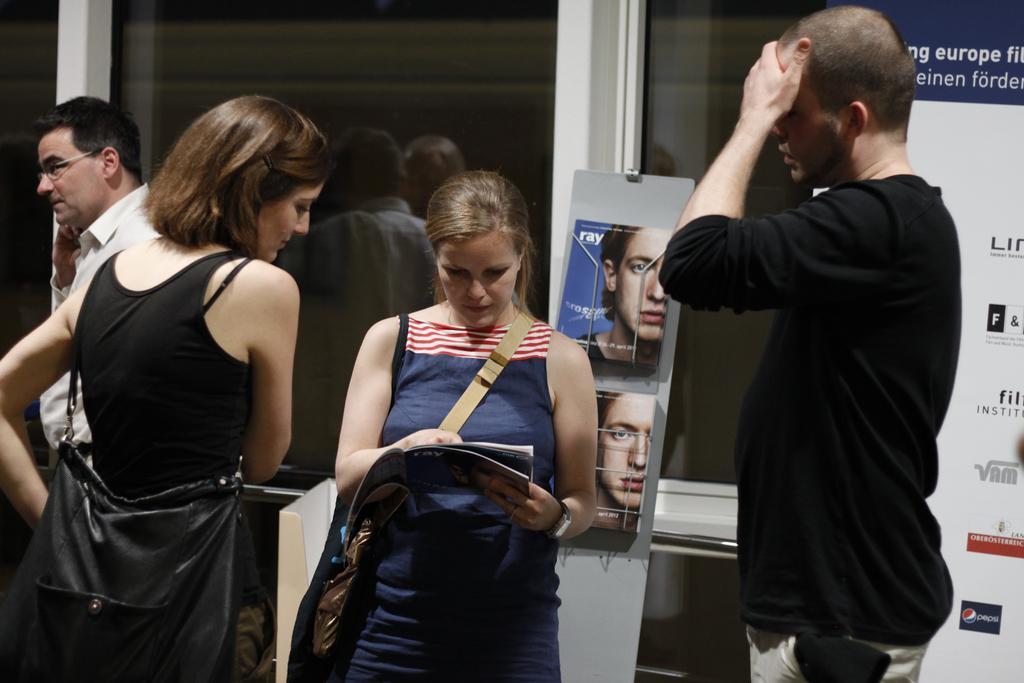In one or two sentences, can you explain what this image depicts? In the foreground of the picture there are two women and a man standing. In the center of the picture there is a woman holding a magazine. In the background there are magazines, stand, banner and windows. On the left there is a person standing near the window. 